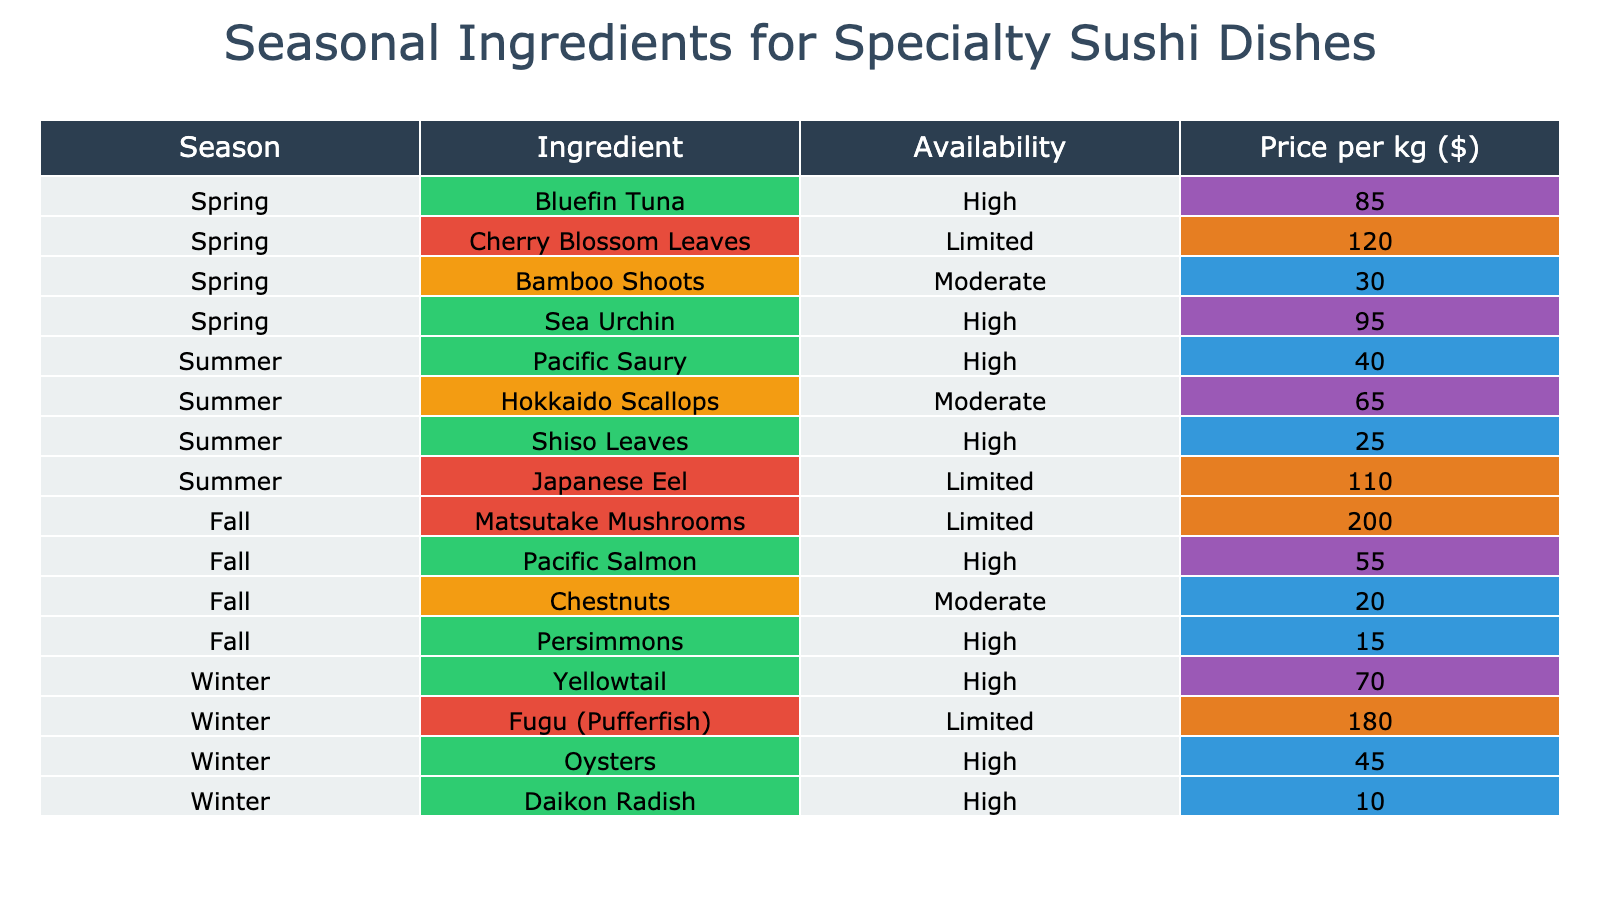What is the price of Bluefin Tuna in spring? The table indicates that the price per kg for Bluefin Tuna during spring is listed directly under the "Price per kg ($)" column corresponding to spring. That value is 85.
Answer: 85 Which season has the highest price for ingredients? To determine this, I compare the maximum values in the "Price per kg ($)" column for each season. Spring has 120 (Cherry Blossom Leaves), Summer has 110 (Japanese Eel), Fall has 200 (Matsutake Mushrooms), and Winter has 180 (Fugu). The highest price is 200 in Fall.
Answer: Fall What ingredients are available in summer? By checking the "Availability" column for the summer season, I see that there are indicators for several ingredients: Pacific Saury, Hokkaido Scallops, Shiso Leaves, and Japanese Eel. Therefore, those four ingredients are available in summer.
Answer: Pacific Saury, Hokkaido Scallops, Shiso Leaves, Japanese Eel Is Fugu available in winter? The table shows that Fugu (Pufferfish) falls under the winter season and its availability is marked as "Limited." Since it's listed as available albeit in limited quantities, I can confirm that it is available.
Answer: Yes What is the average price of ingredients available in fall? I will calculate the average price of the three ingredients available in fall: Pacific Salmon (55), Matsutake Mushrooms (200), Chestnuts (20), and Persimmons (15). The sum is 55 + 200 + 20 + 15 = 290. With 4 ingredients, the average price is 290 / 4 = 72.5.
Answer: 72.5 How many ingredients have "High" availability in spring? Referring to the availability column for spring, I can count the ingredients: Bluefin Tuna, Sea Urchin, and Bamboo Shoots. There are 3 ingredients that are labeled with "High" availability in spring.
Answer: 2 Which ingredients are both high availability and low price (under 50)? I review the table by looking for ingredients where 'Availability' is High and 'Price per kg ($)' is less than 50. The only ingredient meeting these criteria is Daikon Radish, whose price is 10.
Answer: Daikon Radish Are there any "Moderate" availability ingredients in winter? The table indicates that all ingredients in the winter season are either high or limited. Specifically, Daikon Radish (High), Yellowtail (High), Fugu (Limited), and Oysters (High). Therefore, there are no ingredients labeled as "Moderate" availability during winter.
Answer: No 